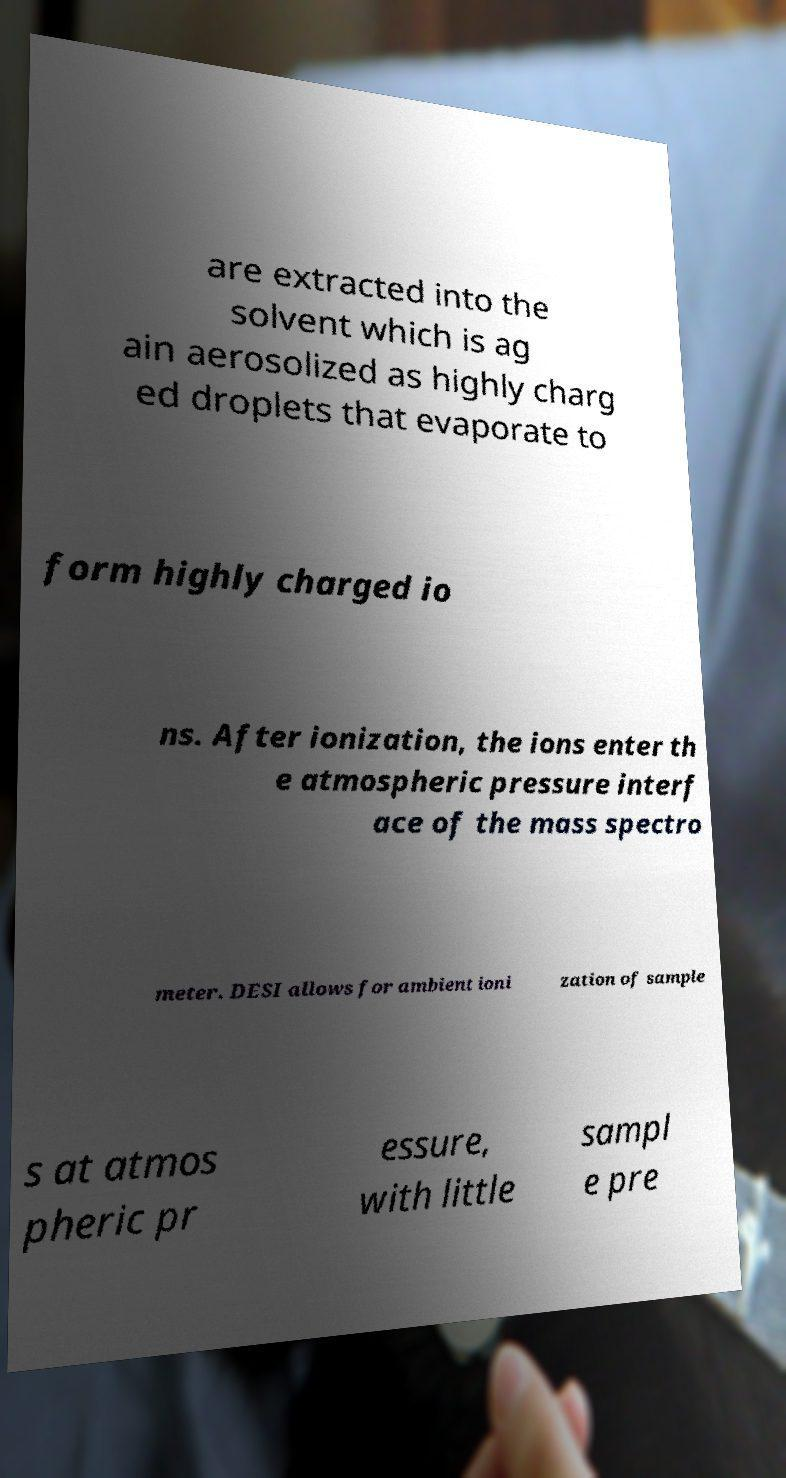I need the written content from this picture converted into text. Can you do that? are extracted into the solvent which is ag ain aerosolized as highly charg ed droplets that evaporate to form highly charged io ns. After ionization, the ions enter th e atmospheric pressure interf ace of the mass spectro meter. DESI allows for ambient ioni zation of sample s at atmos pheric pr essure, with little sampl e pre 